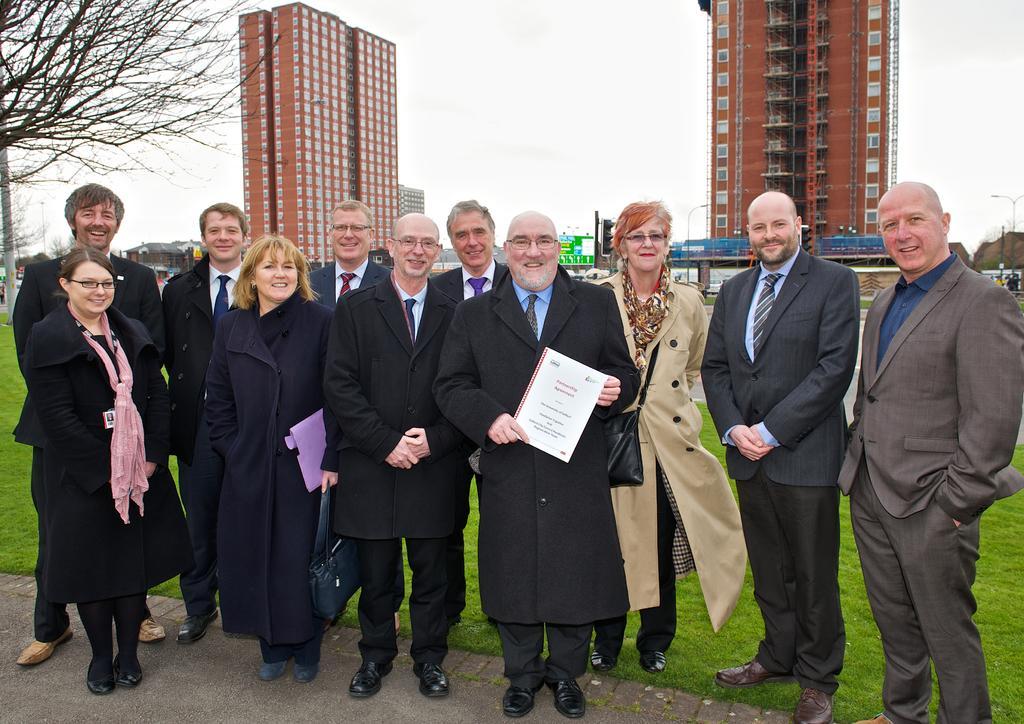In one or two sentences, can you explain what this image depicts? In the image there are few men and women in suits standing in the front and behind them there is grassland and a tree on the left side and in the background there are buildings and above its sky. 